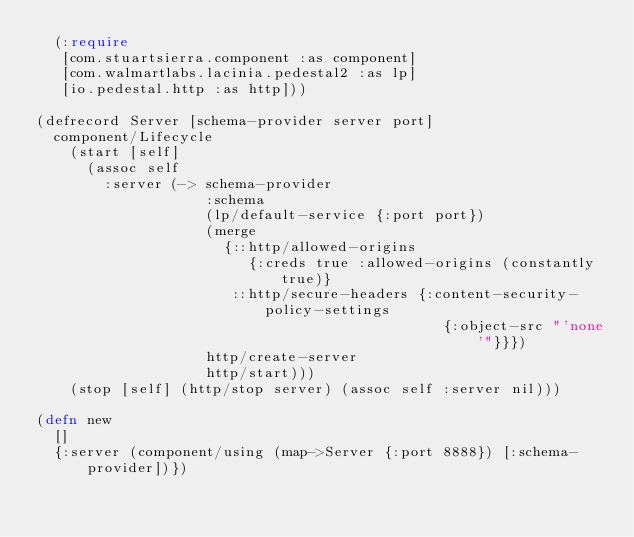Convert code to text. <code><loc_0><loc_0><loc_500><loc_500><_Clojure_>  (:require
   [com.stuartsierra.component :as component]
   [com.walmartlabs.lacinia.pedestal2 :as lp]
   [io.pedestal.http :as http]))

(defrecord Server [schema-provider server port]
  component/Lifecycle
    (start [self]
      (assoc self
        :server (-> schema-provider
                    :schema
                    (lp/default-service {:port port})
                    (merge
                      {::http/allowed-origins
                         {:creds true :allowed-origins (constantly true)}
                       ::http/secure-headers {:content-security-policy-settings
                                                {:object-src "'none'"}}})
                    http/create-server
                    http/start)))
    (stop [self] (http/stop server) (assoc self :server nil)))

(defn new
  []
  {:server (component/using (map->Server {:port 8888}) [:schema-provider])})
</code> 